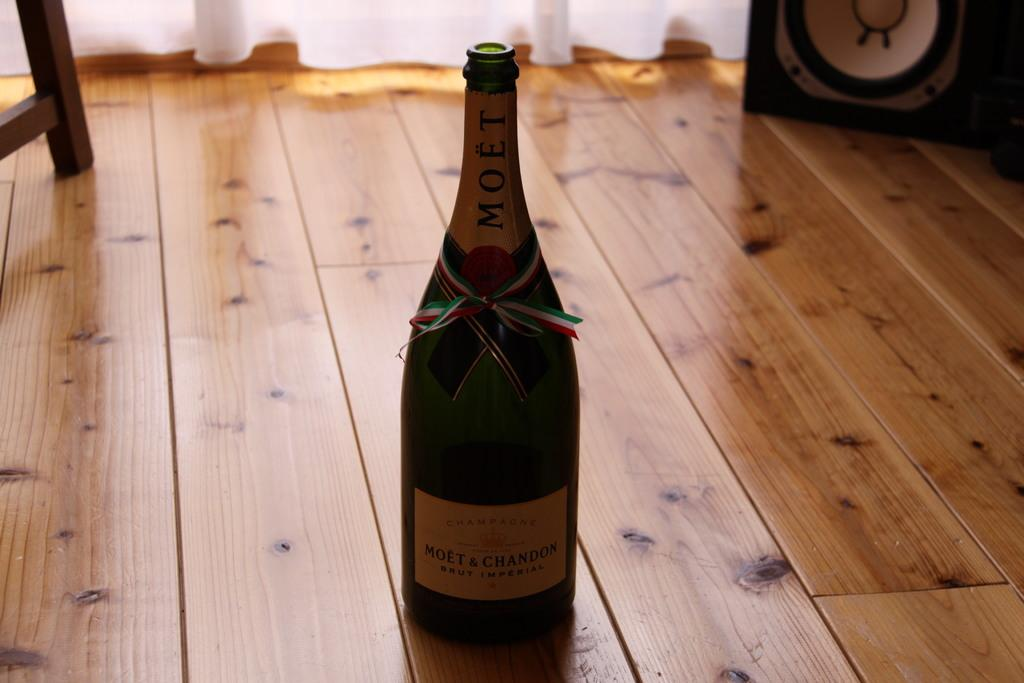<image>
Describe the image concisely. A Moet brand bottle is on a wood surface. 